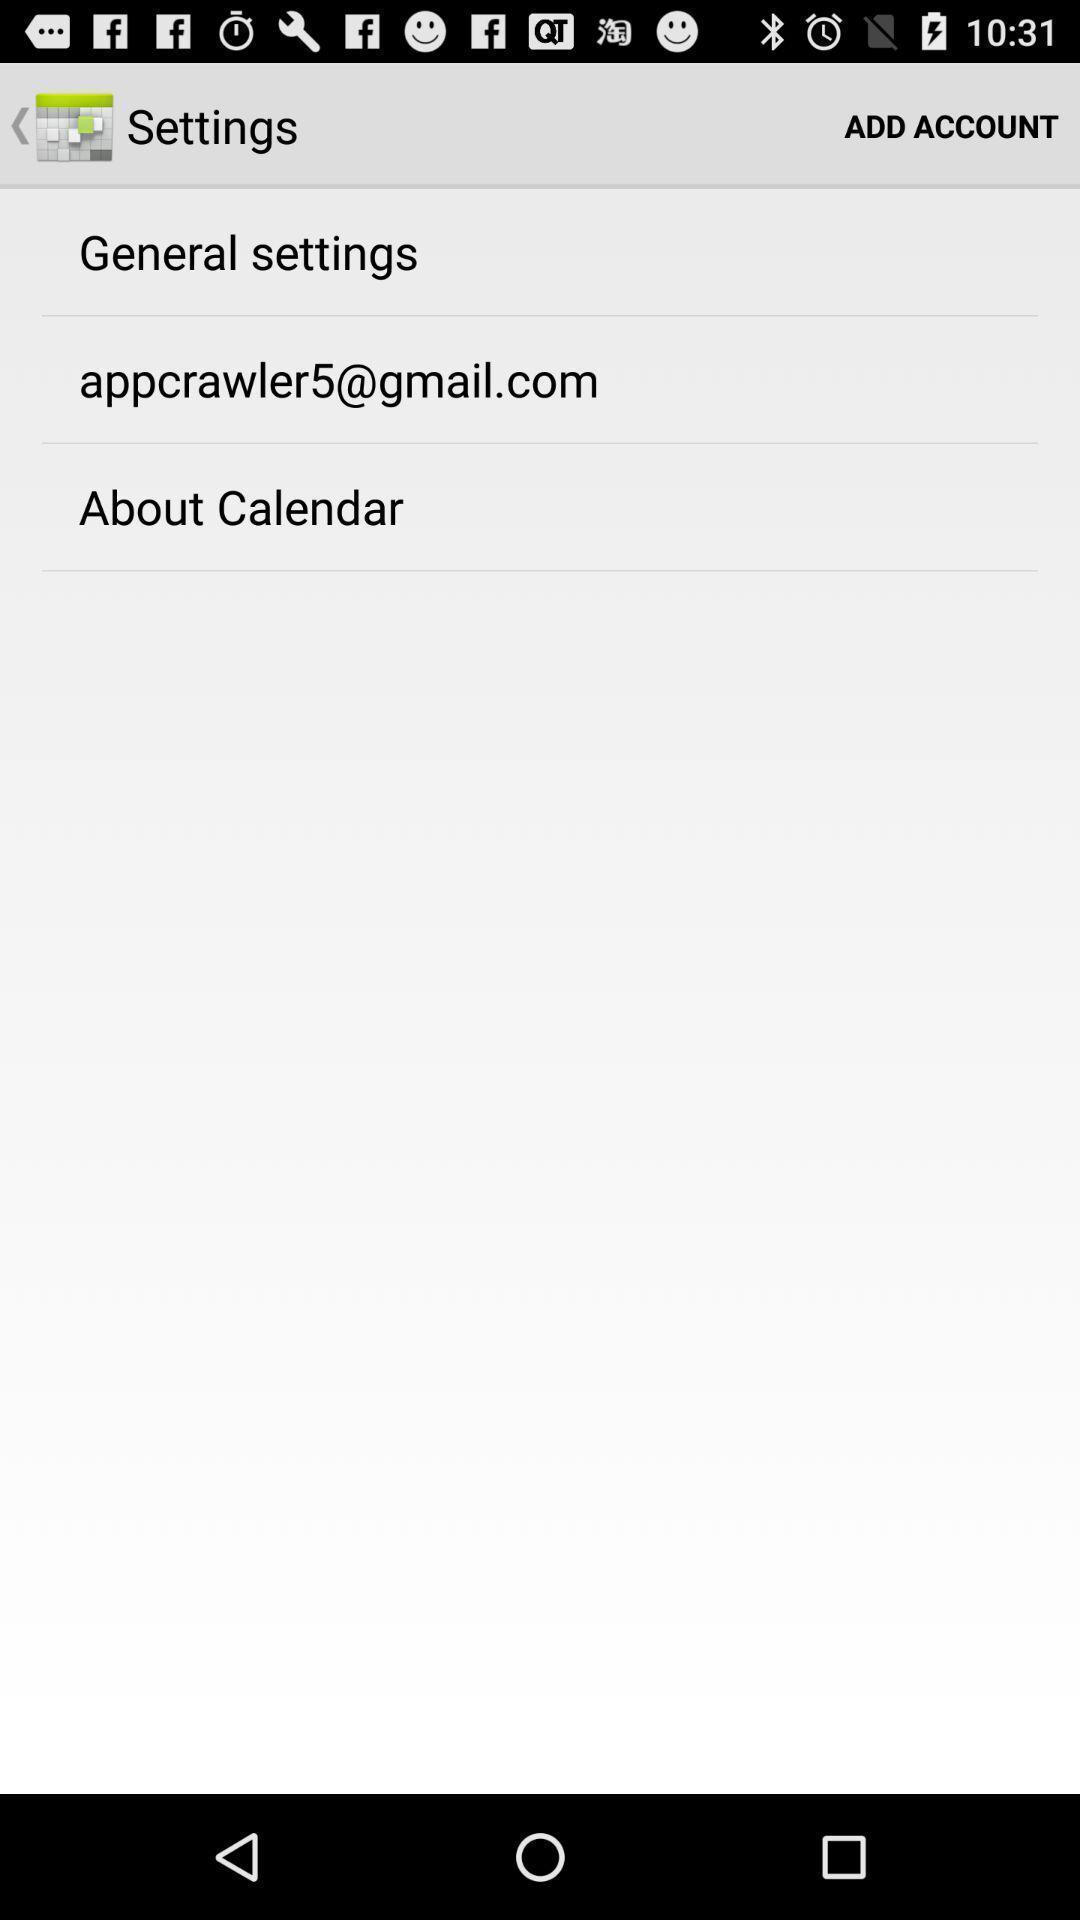Describe the visual elements of this screenshot. Page displaying with list of different settings. 